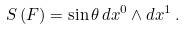<formula> <loc_0><loc_0><loc_500><loc_500>S \left ( F \right ) = \sin \theta \, d x ^ { 0 } \wedge d x ^ { 1 } \, .</formula> 